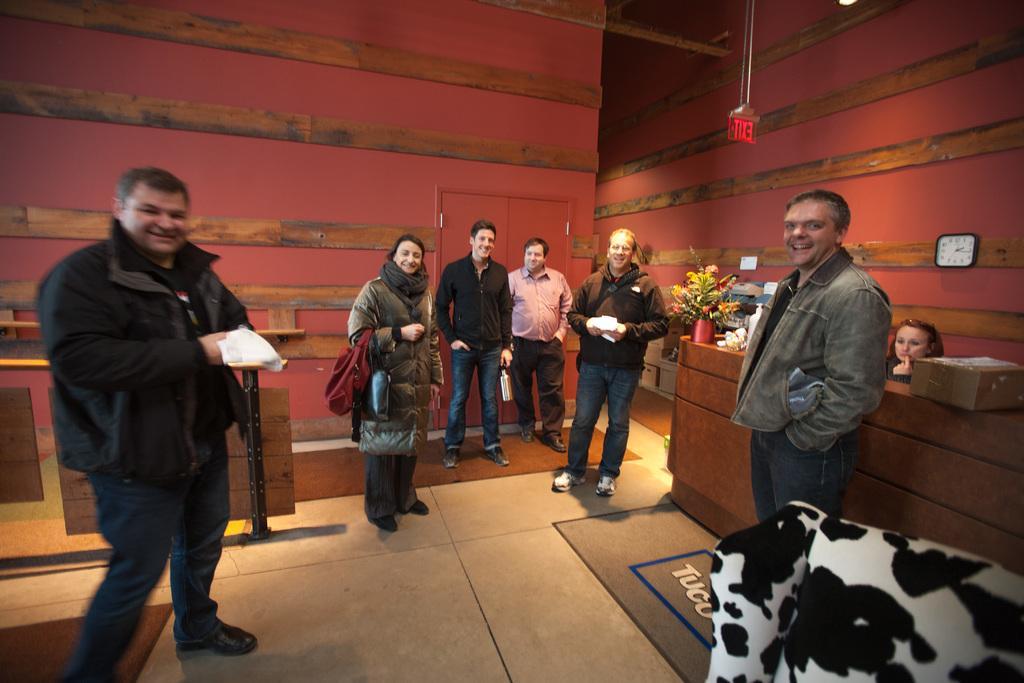Could you give a brief overview of what you see in this image? In this image, I can see few people standing and there are carpets and a floor mat on the floor. On the right side of the image, I can see a wall clock attached to the wall. There is a flower vase, cardboard box and few other objects on a table. Behind the table, I can see a woman. At the top of the image, I can see an exit board hanging with a rope. 